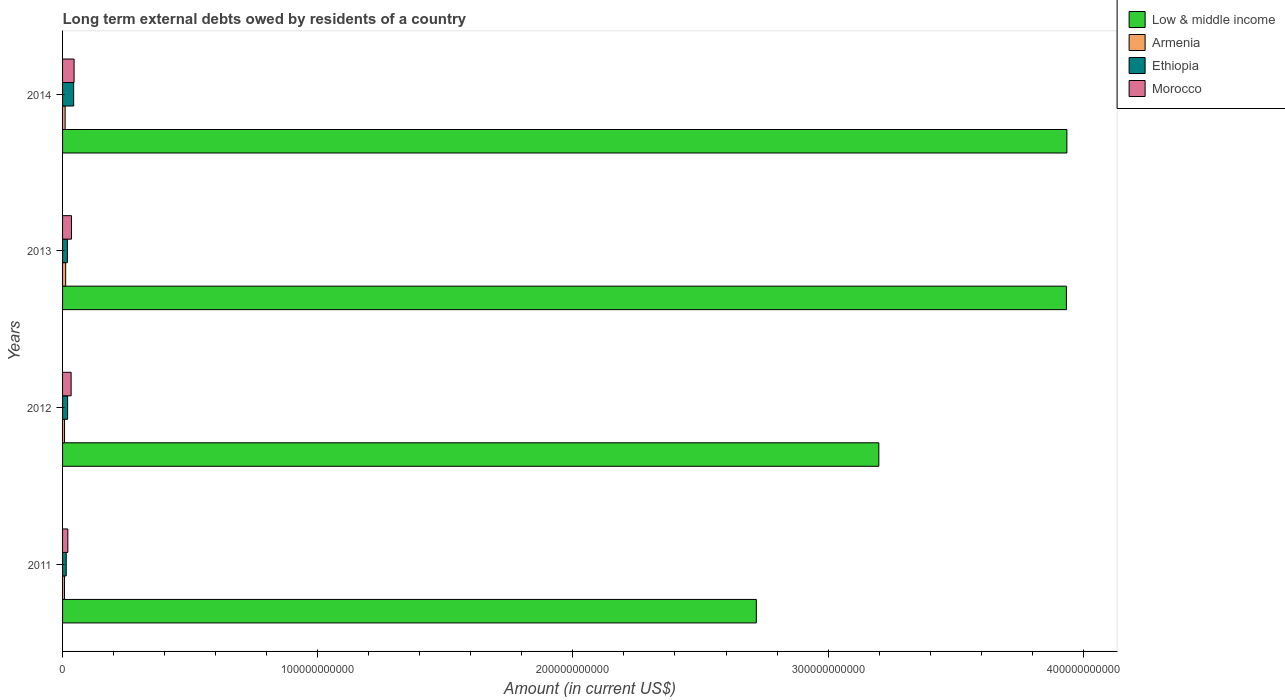How many different coloured bars are there?
Make the answer very short. 4. Are the number of bars on each tick of the Y-axis equal?
Make the answer very short. Yes. What is the amount of long-term external debts owed by residents in Low & middle income in 2013?
Make the answer very short. 3.93e+11. Across all years, what is the maximum amount of long-term external debts owed by residents in Low & middle income?
Give a very brief answer. 3.94e+11. Across all years, what is the minimum amount of long-term external debts owed by residents in Morocco?
Your response must be concise. 2.07e+09. In which year was the amount of long-term external debts owed by residents in Low & middle income maximum?
Your answer should be very brief. 2014. In which year was the amount of long-term external debts owed by residents in Morocco minimum?
Offer a terse response. 2011. What is the total amount of long-term external debts owed by residents in Low & middle income in the graph?
Make the answer very short. 1.38e+12. What is the difference between the amount of long-term external debts owed by residents in Low & middle income in 2011 and that in 2014?
Offer a very short reply. -1.22e+11. What is the difference between the amount of long-term external debts owed by residents in Morocco in 2011 and the amount of long-term external debts owed by residents in Ethiopia in 2012?
Keep it short and to the point. 8.87e+07. What is the average amount of long-term external debts owed by residents in Low & middle income per year?
Provide a short and direct response. 3.45e+11. In the year 2012, what is the difference between the amount of long-term external debts owed by residents in Low & middle income and amount of long-term external debts owed by residents in Ethiopia?
Offer a terse response. 3.18e+11. What is the ratio of the amount of long-term external debts owed by residents in Low & middle income in 2011 to that in 2012?
Your answer should be very brief. 0.85. Is the amount of long-term external debts owed by residents in Ethiopia in 2012 less than that in 2013?
Make the answer very short. No. What is the difference between the highest and the second highest amount of long-term external debts owed by residents in Ethiopia?
Offer a very short reply. 2.36e+09. What is the difference between the highest and the lowest amount of long-term external debts owed by residents in Ethiopia?
Offer a terse response. 2.91e+09. Is the sum of the amount of long-term external debts owed by residents in Morocco in 2011 and 2012 greater than the maximum amount of long-term external debts owed by residents in Low & middle income across all years?
Provide a short and direct response. No. What does the 2nd bar from the top in 2012 represents?
Give a very brief answer. Ethiopia. What does the 3rd bar from the bottom in 2011 represents?
Keep it short and to the point. Ethiopia. How many bars are there?
Make the answer very short. 16. Are all the bars in the graph horizontal?
Offer a very short reply. Yes. How many years are there in the graph?
Your answer should be compact. 4. What is the difference between two consecutive major ticks on the X-axis?
Provide a short and direct response. 1.00e+11. Are the values on the major ticks of X-axis written in scientific E-notation?
Offer a terse response. No. Does the graph contain grids?
Offer a terse response. No. Where does the legend appear in the graph?
Keep it short and to the point. Top right. How are the legend labels stacked?
Offer a very short reply. Vertical. What is the title of the graph?
Provide a short and direct response. Long term external debts owed by residents of a country. What is the label or title of the X-axis?
Your response must be concise. Amount (in current US$). What is the Amount (in current US$) in Low & middle income in 2011?
Make the answer very short. 2.72e+11. What is the Amount (in current US$) in Armenia in 2011?
Keep it short and to the point. 7.48e+08. What is the Amount (in current US$) of Ethiopia in 2011?
Your response must be concise. 1.43e+09. What is the Amount (in current US$) in Morocco in 2011?
Your response must be concise. 2.07e+09. What is the Amount (in current US$) in Low & middle income in 2012?
Provide a short and direct response. 3.20e+11. What is the Amount (in current US$) of Armenia in 2012?
Provide a short and direct response. 7.79e+08. What is the Amount (in current US$) of Ethiopia in 2012?
Your answer should be compact. 1.98e+09. What is the Amount (in current US$) of Morocco in 2012?
Keep it short and to the point. 3.35e+09. What is the Amount (in current US$) in Low & middle income in 2013?
Your answer should be very brief. 3.93e+11. What is the Amount (in current US$) in Armenia in 2013?
Ensure brevity in your answer.  1.22e+09. What is the Amount (in current US$) in Ethiopia in 2013?
Provide a short and direct response. 1.90e+09. What is the Amount (in current US$) of Morocco in 2013?
Your answer should be compact. 3.49e+09. What is the Amount (in current US$) of Low & middle income in 2014?
Your answer should be compact. 3.94e+11. What is the Amount (in current US$) in Armenia in 2014?
Offer a very short reply. 1.00e+09. What is the Amount (in current US$) in Ethiopia in 2014?
Offer a terse response. 4.35e+09. What is the Amount (in current US$) in Morocco in 2014?
Make the answer very short. 4.51e+09. Across all years, what is the maximum Amount (in current US$) in Low & middle income?
Your response must be concise. 3.94e+11. Across all years, what is the maximum Amount (in current US$) in Armenia?
Provide a short and direct response. 1.22e+09. Across all years, what is the maximum Amount (in current US$) of Ethiopia?
Keep it short and to the point. 4.35e+09. Across all years, what is the maximum Amount (in current US$) in Morocco?
Your answer should be very brief. 4.51e+09. Across all years, what is the minimum Amount (in current US$) in Low & middle income?
Offer a very short reply. 2.72e+11. Across all years, what is the minimum Amount (in current US$) of Armenia?
Offer a very short reply. 7.48e+08. Across all years, what is the minimum Amount (in current US$) in Ethiopia?
Make the answer very short. 1.43e+09. Across all years, what is the minimum Amount (in current US$) of Morocco?
Your answer should be compact. 2.07e+09. What is the total Amount (in current US$) of Low & middle income in the graph?
Your answer should be compact. 1.38e+12. What is the total Amount (in current US$) of Armenia in the graph?
Offer a very short reply. 3.75e+09. What is the total Amount (in current US$) of Ethiopia in the graph?
Offer a terse response. 9.66e+09. What is the total Amount (in current US$) in Morocco in the graph?
Give a very brief answer. 1.34e+1. What is the difference between the Amount (in current US$) of Low & middle income in 2011 and that in 2012?
Your answer should be compact. -4.80e+1. What is the difference between the Amount (in current US$) in Armenia in 2011 and that in 2012?
Provide a short and direct response. -3.09e+07. What is the difference between the Amount (in current US$) of Ethiopia in 2011 and that in 2012?
Your response must be concise. -5.47e+08. What is the difference between the Amount (in current US$) in Morocco in 2011 and that in 2012?
Give a very brief answer. -1.28e+09. What is the difference between the Amount (in current US$) in Low & middle income in 2011 and that in 2013?
Ensure brevity in your answer.  -1.22e+11. What is the difference between the Amount (in current US$) in Armenia in 2011 and that in 2013?
Offer a terse response. -4.70e+08. What is the difference between the Amount (in current US$) in Ethiopia in 2011 and that in 2013?
Your answer should be compact. -4.62e+08. What is the difference between the Amount (in current US$) of Morocco in 2011 and that in 2013?
Your answer should be compact. -1.42e+09. What is the difference between the Amount (in current US$) of Low & middle income in 2011 and that in 2014?
Offer a very short reply. -1.22e+11. What is the difference between the Amount (in current US$) of Armenia in 2011 and that in 2014?
Ensure brevity in your answer.  -2.55e+08. What is the difference between the Amount (in current US$) of Ethiopia in 2011 and that in 2014?
Ensure brevity in your answer.  -2.91e+09. What is the difference between the Amount (in current US$) in Morocco in 2011 and that in 2014?
Ensure brevity in your answer.  -2.44e+09. What is the difference between the Amount (in current US$) in Low & middle income in 2012 and that in 2013?
Your answer should be compact. -7.35e+1. What is the difference between the Amount (in current US$) of Armenia in 2012 and that in 2013?
Your answer should be very brief. -4.39e+08. What is the difference between the Amount (in current US$) in Ethiopia in 2012 and that in 2013?
Make the answer very short. 8.51e+07. What is the difference between the Amount (in current US$) in Morocco in 2012 and that in 2013?
Make the answer very short. -1.36e+08. What is the difference between the Amount (in current US$) in Low & middle income in 2012 and that in 2014?
Offer a terse response. -7.37e+1. What is the difference between the Amount (in current US$) in Armenia in 2012 and that in 2014?
Offer a very short reply. -2.24e+08. What is the difference between the Amount (in current US$) of Ethiopia in 2012 and that in 2014?
Offer a terse response. -2.36e+09. What is the difference between the Amount (in current US$) in Morocco in 2012 and that in 2014?
Give a very brief answer. -1.16e+09. What is the difference between the Amount (in current US$) in Low & middle income in 2013 and that in 2014?
Provide a short and direct response. -1.86e+08. What is the difference between the Amount (in current US$) of Armenia in 2013 and that in 2014?
Keep it short and to the point. 2.14e+08. What is the difference between the Amount (in current US$) of Ethiopia in 2013 and that in 2014?
Provide a short and direct response. -2.45e+09. What is the difference between the Amount (in current US$) in Morocco in 2013 and that in 2014?
Provide a succinct answer. -1.02e+09. What is the difference between the Amount (in current US$) of Low & middle income in 2011 and the Amount (in current US$) of Armenia in 2012?
Give a very brief answer. 2.71e+11. What is the difference between the Amount (in current US$) of Low & middle income in 2011 and the Amount (in current US$) of Ethiopia in 2012?
Keep it short and to the point. 2.70e+11. What is the difference between the Amount (in current US$) in Low & middle income in 2011 and the Amount (in current US$) in Morocco in 2012?
Your answer should be very brief. 2.69e+11. What is the difference between the Amount (in current US$) in Armenia in 2011 and the Amount (in current US$) in Ethiopia in 2012?
Provide a short and direct response. -1.23e+09. What is the difference between the Amount (in current US$) of Armenia in 2011 and the Amount (in current US$) of Morocco in 2012?
Your answer should be compact. -2.60e+09. What is the difference between the Amount (in current US$) in Ethiopia in 2011 and the Amount (in current US$) in Morocco in 2012?
Offer a very short reply. -1.92e+09. What is the difference between the Amount (in current US$) in Low & middle income in 2011 and the Amount (in current US$) in Armenia in 2013?
Provide a short and direct response. 2.71e+11. What is the difference between the Amount (in current US$) in Low & middle income in 2011 and the Amount (in current US$) in Ethiopia in 2013?
Your answer should be very brief. 2.70e+11. What is the difference between the Amount (in current US$) of Low & middle income in 2011 and the Amount (in current US$) of Morocco in 2013?
Your answer should be compact. 2.68e+11. What is the difference between the Amount (in current US$) in Armenia in 2011 and the Amount (in current US$) in Ethiopia in 2013?
Offer a very short reply. -1.15e+09. What is the difference between the Amount (in current US$) of Armenia in 2011 and the Amount (in current US$) of Morocco in 2013?
Provide a short and direct response. -2.74e+09. What is the difference between the Amount (in current US$) of Ethiopia in 2011 and the Amount (in current US$) of Morocco in 2013?
Make the answer very short. -2.05e+09. What is the difference between the Amount (in current US$) in Low & middle income in 2011 and the Amount (in current US$) in Armenia in 2014?
Provide a succinct answer. 2.71e+11. What is the difference between the Amount (in current US$) in Low & middle income in 2011 and the Amount (in current US$) in Ethiopia in 2014?
Your response must be concise. 2.68e+11. What is the difference between the Amount (in current US$) in Low & middle income in 2011 and the Amount (in current US$) in Morocco in 2014?
Your answer should be compact. 2.67e+11. What is the difference between the Amount (in current US$) of Armenia in 2011 and the Amount (in current US$) of Ethiopia in 2014?
Give a very brief answer. -3.60e+09. What is the difference between the Amount (in current US$) of Armenia in 2011 and the Amount (in current US$) of Morocco in 2014?
Give a very brief answer. -3.76e+09. What is the difference between the Amount (in current US$) of Ethiopia in 2011 and the Amount (in current US$) of Morocco in 2014?
Provide a short and direct response. -3.08e+09. What is the difference between the Amount (in current US$) of Low & middle income in 2012 and the Amount (in current US$) of Armenia in 2013?
Provide a short and direct response. 3.19e+11. What is the difference between the Amount (in current US$) of Low & middle income in 2012 and the Amount (in current US$) of Ethiopia in 2013?
Ensure brevity in your answer.  3.18e+11. What is the difference between the Amount (in current US$) in Low & middle income in 2012 and the Amount (in current US$) in Morocco in 2013?
Offer a very short reply. 3.16e+11. What is the difference between the Amount (in current US$) of Armenia in 2012 and the Amount (in current US$) of Ethiopia in 2013?
Offer a terse response. -1.12e+09. What is the difference between the Amount (in current US$) of Armenia in 2012 and the Amount (in current US$) of Morocco in 2013?
Give a very brief answer. -2.71e+09. What is the difference between the Amount (in current US$) of Ethiopia in 2012 and the Amount (in current US$) of Morocco in 2013?
Keep it short and to the point. -1.51e+09. What is the difference between the Amount (in current US$) in Low & middle income in 2012 and the Amount (in current US$) in Armenia in 2014?
Offer a very short reply. 3.19e+11. What is the difference between the Amount (in current US$) in Low & middle income in 2012 and the Amount (in current US$) in Ethiopia in 2014?
Offer a terse response. 3.16e+11. What is the difference between the Amount (in current US$) of Low & middle income in 2012 and the Amount (in current US$) of Morocco in 2014?
Ensure brevity in your answer.  3.15e+11. What is the difference between the Amount (in current US$) of Armenia in 2012 and the Amount (in current US$) of Ethiopia in 2014?
Offer a very short reply. -3.57e+09. What is the difference between the Amount (in current US$) in Armenia in 2012 and the Amount (in current US$) in Morocco in 2014?
Keep it short and to the point. -3.73e+09. What is the difference between the Amount (in current US$) of Ethiopia in 2012 and the Amount (in current US$) of Morocco in 2014?
Ensure brevity in your answer.  -2.53e+09. What is the difference between the Amount (in current US$) in Low & middle income in 2013 and the Amount (in current US$) in Armenia in 2014?
Keep it short and to the point. 3.92e+11. What is the difference between the Amount (in current US$) in Low & middle income in 2013 and the Amount (in current US$) in Ethiopia in 2014?
Give a very brief answer. 3.89e+11. What is the difference between the Amount (in current US$) in Low & middle income in 2013 and the Amount (in current US$) in Morocco in 2014?
Your answer should be compact. 3.89e+11. What is the difference between the Amount (in current US$) of Armenia in 2013 and the Amount (in current US$) of Ethiopia in 2014?
Ensure brevity in your answer.  -3.13e+09. What is the difference between the Amount (in current US$) in Armenia in 2013 and the Amount (in current US$) in Morocco in 2014?
Provide a short and direct response. -3.29e+09. What is the difference between the Amount (in current US$) in Ethiopia in 2013 and the Amount (in current US$) in Morocco in 2014?
Keep it short and to the point. -2.61e+09. What is the average Amount (in current US$) of Low & middle income per year?
Ensure brevity in your answer.  3.45e+11. What is the average Amount (in current US$) in Armenia per year?
Your answer should be compact. 9.37e+08. What is the average Amount (in current US$) in Ethiopia per year?
Ensure brevity in your answer.  2.41e+09. What is the average Amount (in current US$) of Morocco per year?
Your response must be concise. 3.36e+09. In the year 2011, what is the difference between the Amount (in current US$) in Low & middle income and Amount (in current US$) in Armenia?
Provide a short and direct response. 2.71e+11. In the year 2011, what is the difference between the Amount (in current US$) of Low & middle income and Amount (in current US$) of Ethiopia?
Provide a succinct answer. 2.70e+11. In the year 2011, what is the difference between the Amount (in current US$) of Low & middle income and Amount (in current US$) of Morocco?
Your answer should be very brief. 2.70e+11. In the year 2011, what is the difference between the Amount (in current US$) of Armenia and Amount (in current US$) of Ethiopia?
Make the answer very short. -6.86e+08. In the year 2011, what is the difference between the Amount (in current US$) in Armenia and Amount (in current US$) in Morocco?
Make the answer very short. -1.32e+09. In the year 2011, what is the difference between the Amount (in current US$) in Ethiopia and Amount (in current US$) in Morocco?
Your answer should be compact. -6.36e+08. In the year 2012, what is the difference between the Amount (in current US$) of Low & middle income and Amount (in current US$) of Armenia?
Offer a terse response. 3.19e+11. In the year 2012, what is the difference between the Amount (in current US$) of Low & middle income and Amount (in current US$) of Ethiopia?
Your answer should be very brief. 3.18e+11. In the year 2012, what is the difference between the Amount (in current US$) of Low & middle income and Amount (in current US$) of Morocco?
Offer a terse response. 3.17e+11. In the year 2012, what is the difference between the Amount (in current US$) in Armenia and Amount (in current US$) in Ethiopia?
Offer a terse response. -1.20e+09. In the year 2012, what is the difference between the Amount (in current US$) of Armenia and Amount (in current US$) of Morocco?
Your answer should be very brief. -2.57e+09. In the year 2012, what is the difference between the Amount (in current US$) of Ethiopia and Amount (in current US$) of Morocco?
Provide a succinct answer. -1.37e+09. In the year 2013, what is the difference between the Amount (in current US$) of Low & middle income and Amount (in current US$) of Armenia?
Make the answer very short. 3.92e+11. In the year 2013, what is the difference between the Amount (in current US$) in Low & middle income and Amount (in current US$) in Ethiopia?
Keep it short and to the point. 3.91e+11. In the year 2013, what is the difference between the Amount (in current US$) of Low & middle income and Amount (in current US$) of Morocco?
Your answer should be compact. 3.90e+11. In the year 2013, what is the difference between the Amount (in current US$) of Armenia and Amount (in current US$) of Ethiopia?
Your answer should be very brief. -6.78e+08. In the year 2013, what is the difference between the Amount (in current US$) of Armenia and Amount (in current US$) of Morocco?
Keep it short and to the point. -2.27e+09. In the year 2013, what is the difference between the Amount (in current US$) in Ethiopia and Amount (in current US$) in Morocco?
Ensure brevity in your answer.  -1.59e+09. In the year 2014, what is the difference between the Amount (in current US$) of Low & middle income and Amount (in current US$) of Armenia?
Ensure brevity in your answer.  3.93e+11. In the year 2014, what is the difference between the Amount (in current US$) of Low & middle income and Amount (in current US$) of Ethiopia?
Give a very brief answer. 3.89e+11. In the year 2014, what is the difference between the Amount (in current US$) of Low & middle income and Amount (in current US$) of Morocco?
Keep it short and to the point. 3.89e+11. In the year 2014, what is the difference between the Amount (in current US$) of Armenia and Amount (in current US$) of Ethiopia?
Ensure brevity in your answer.  -3.34e+09. In the year 2014, what is the difference between the Amount (in current US$) of Armenia and Amount (in current US$) of Morocco?
Your response must be concise. -3.51e+09. In the year 2014, what is the difference between the Amount (in current US$) of Ethiopia and Amount (in current US$) of Morocco?
Your answer should be very brief. -1.65e+08. What is the ratio of the Amount (in current US$) of Low & middle income in 2011 to that in 2012?
Your response must be concise. 0.85. What is the ratio of the Amount (in current US$) of Armenia in 2011 to that in 2012?
Offer a very short reply. 0.96. What is the ratio of the Amount (in current US$) of Ethiopia in 2011 to that in 2012?
Ensure brevity in your answer.  0.72. What is the ratio of the Amount (in current US$) in Morocco in 2011 to that in 2012?
Offer a terse response. 0.62. What is the ratio of the Amount (in current US$) of Low & middle income in 2011 to that in 2013?
Offer a very short reply. 0.69. What is the ratio of the Amount (in current US$) in Armenia in 2011 to that in 2013?
Offer a very short reply. 0.61. What is the ratio of the Amount (in current US$) of Ethiopia in 2011 to that in 2013?
Offer a terse response. 0.76. What is the ratio of the Amount (in current US$) of Morocco in 2011 to that in 2013?
Make the answer very short. 0.59. What is the ratio of the Amount (in current US$) in Low & middle income in 2011 to that in 2014?
Provide a succinct answer. 0.69. What is the ratio of the Amount (in current US$) in Armenia in 2011 to that in 2014?
Make the answer very short. 0.75. What is the ratio of the Amount (in current US$) in Ethiopia in 2011 to that in 2014?
Provide a succinct answer. 0.33. What is the ratio of the Amount (in current US$) in Morocco in 2011 to that in 2014?
Provide a short and direct response. 0.46. What is the ratio of the Amount (in current US$) in Low & middle income in 2012 to that in 2013?
Give a very brief answer. 0.81. What is the ratio of the Amount (in current US$) in Armenia in 2012 to that in 2013?
Offer a very short reply. 0.64. What is the ratio of the Amount (in current US$) in Ethiopia in 2012 to that in 2013?
Your response must be concise. 1.04. What is the ratio of the Amount (in current US$) in Morocco in 2012 to that in 2013?
Your response must be concise. 0.96. What is the ratio of the Amount (in current US$) in Low & middle income in 2012 to that in 2014?
Your answer should be compact. 0.81. What is the ratio of the Amount (in current US$) in Armenia in 2012 to that in 2014?
Offer a very short reply. 0.78. What is the ratio of the Amount (in current US$) of Ethiopia in 2012 to that in 2014?
Provide a short and direct response. 0.46. What is the ratio of the Amount (in current US$) in Morocco in 2012 to that in 2014?
Make the answer very short. 0.74. What is the ratio of the Amount (in current US$) in Low & middle income in 2013 to that in 2014?
Offer a very short reply. 1. What is the ratio of the Amount (in current US$) in Armenia in 2013 to that in 2014?
Your answer should be very brief. 1.21. What is the ratio of the Amount (in current US$) of Ethiopia in 2013 to that in 2014?
Offer a terse response. 0.44. What is the ratio of the Amount (in current US$) in Morocco in 2013 to that in 2014?
Keep it short and to the point. 0.77. What is the difference between the highest and the second highest Amount (in current US$) in Low & middle income?
Your answer should be compact. 1.86e+08. What is the difference between the highest and the second highest Amount (in current US$) in Armenia?
Provide a succinct answer. 2.14e+08. What is the difference between the highest and the second highest Amount (in current US$) of Ethiopia?
Ensure brevity in your answer.  2.36e+09. What is the difference between the highest and the second highest Amount (in current US$) in Morocco?
Offer a terse response. 1.02e+09. What is the difference between the highest and the lowest Amount (in current US$) of Low & middle income?
Keep it short and to the point. 1.22e+11. What is the difference between the highest and the lowest Amount (in current US$) of Armenia?
Offer a terse response. 4.70e+08. What is the difference between the highest and the lowest Amount (in current US$) of Ethiopia?
Offer a terse response. 2.91e+09. What is the difference between the highest and the lowest Amount (in current US$) of Morocco?
Your answer should be very brief. 2.44e+09. 